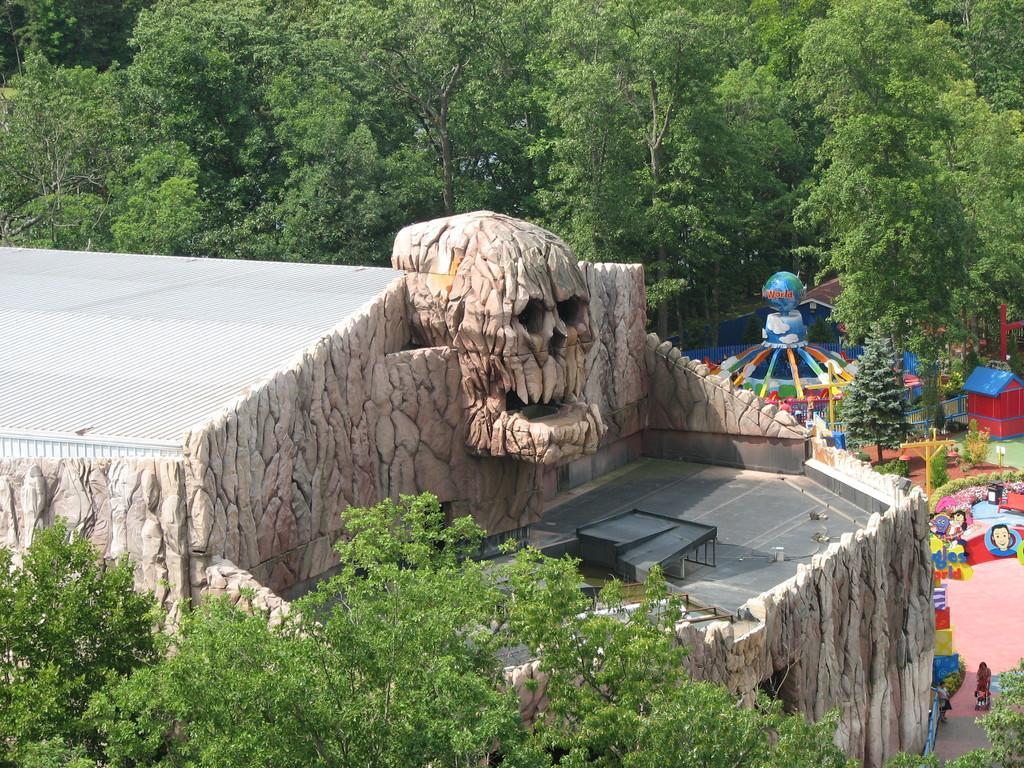Please provide a concise description of this image. In this image at the bottom we can see trees, on the left side there is a building, objects on the floor. In the background there are trees, amusing rides, poles and objects. 